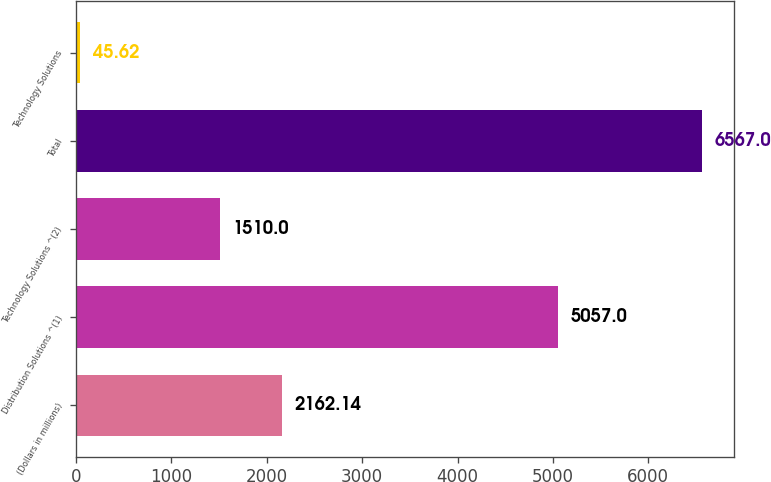Convert chart. <chart><loc_0><loc_0><loc_500><loc_500><bar_chart><fcel>(Dollars in millions)<fcel>Distribution Solutions ^(1)<fcel>Technology Solutions ^(2)<fcel>Total<fcel>Technology Solutions<nl><fcel>2162.14<fcel>5057<fcel>1510<fcel>6567<fcel>45.62<nl></chart> 